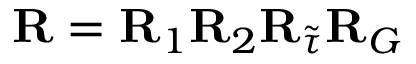Convert formula to latex. <formula><loc_0><loc_0><loc_500><loc_500>{ R } = { R } _ { 1 } { R } _ { 2 } { R } _ { \tilde { \tau } } { R } _ { G }</formula> 